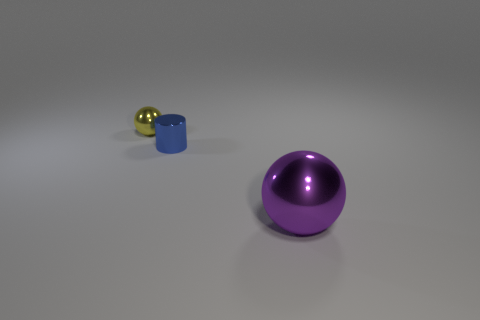Add 1 big cyan rubber balls. How many objects exist? 4 Subtract all balls. How many objects are left? 1 Add 1 tiny green rubber balls. How many tiny green rubber balls exist? 1 Subtract 0 gray blocks. How many objects are left? 3 Subtract all tiny cyan objects. Subtract all metal spheres. How many objects are left? 1 Add 2 small metal cylinders. How many small metal cylinders are left? 3 